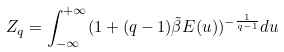Convert formula to latex. <formula><loc_0><loc_0><loc_500><loc_500>Z _ { q } = \int _ { - \infty } ^ { + \infty } ( 1 + ( q - 1 ) \tilde { \beta } E ( u ) ) ^ { - \frac { 1 } { q - 1 } } d u</formula> 